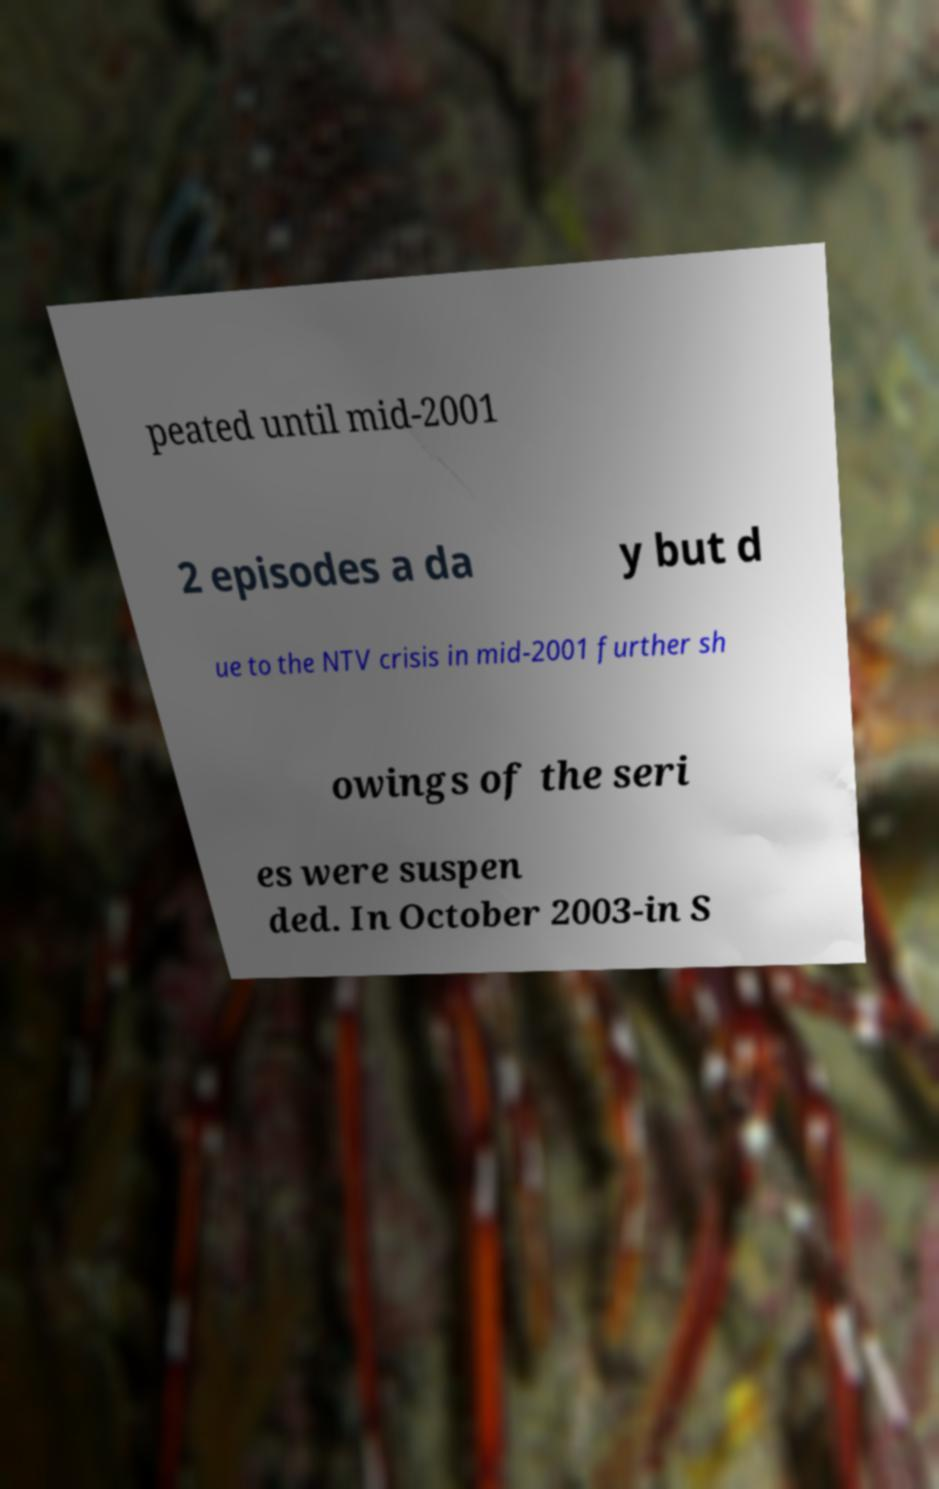I need the written content from this picture converted into text. Can you do that? peated until mid-2001 2 episodes a da y but d ue to the NTV crisis in mid-2001 further sh owings of the seri es were suspen ded. In October 2003-in S 